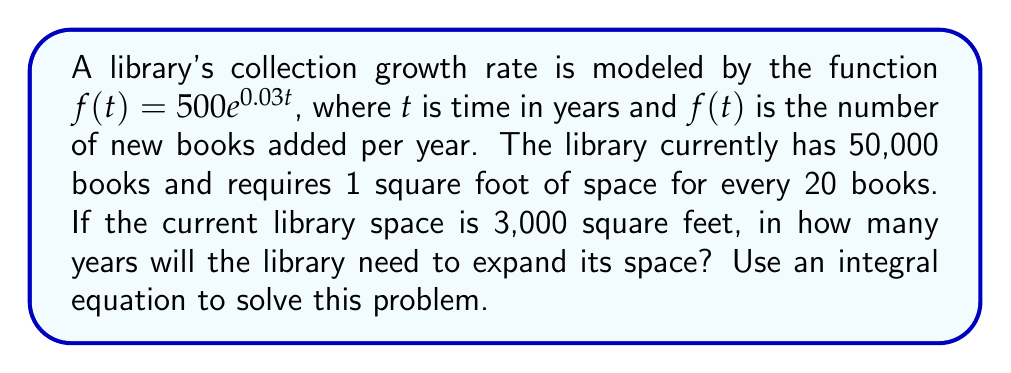Can you solve this math problem? Let's approach this step-by-step:

1) First, we need to find the total number of books after $t$ years. This can be expressed as an integral equation:

   $\text{Total books} = 50000 + \int_0^t 500e^{0.03x} dx$

2) Solve the integral:
   
   $\int_0^t 500e^{0.03x} dx = \frac{500}{0.03}[e^{0.03t} - 1] \approx 16667(e^{0.03t} - 1)$

3) So, the total number of books after $t$ years is:

   $\text{Total books} = 50000 + 16667(e^{0.03t} - 1)$

4) The space required (in square feet) is:

   $\text{Space required} = \frac{50000 + 16667(e^{0.03t} - 1)}{20}$

5) We need to find $t$ when this equals 3000:

   $3000 = \frac{50000 + 16667(e^{0.03t} - 1)}{20}$

6) Multiply both sides by 20:

   $60000 = 50000 + 16667(e^{0.03t} - 1)$

7) Subtract 50000 from both sides:

   $10000 = 16667(e^{0.03t} - 1)$

8) Divide both sides by 16667:

   $0.6 = e^{0.03t} - 1$

9) Add 1 to both sides:

   $1.6 = e^{0.03t}$

10) Take the natural log of both sides:

    $\ln(1.6) = 0.03t$

11) Solve for $t$:

    $t = \frac{\ln(1.6)}{0.03} \approx 15.64$

Therefore, the library will need to expand its space in approximately 15.64 years.
Answer: 15.64 years 